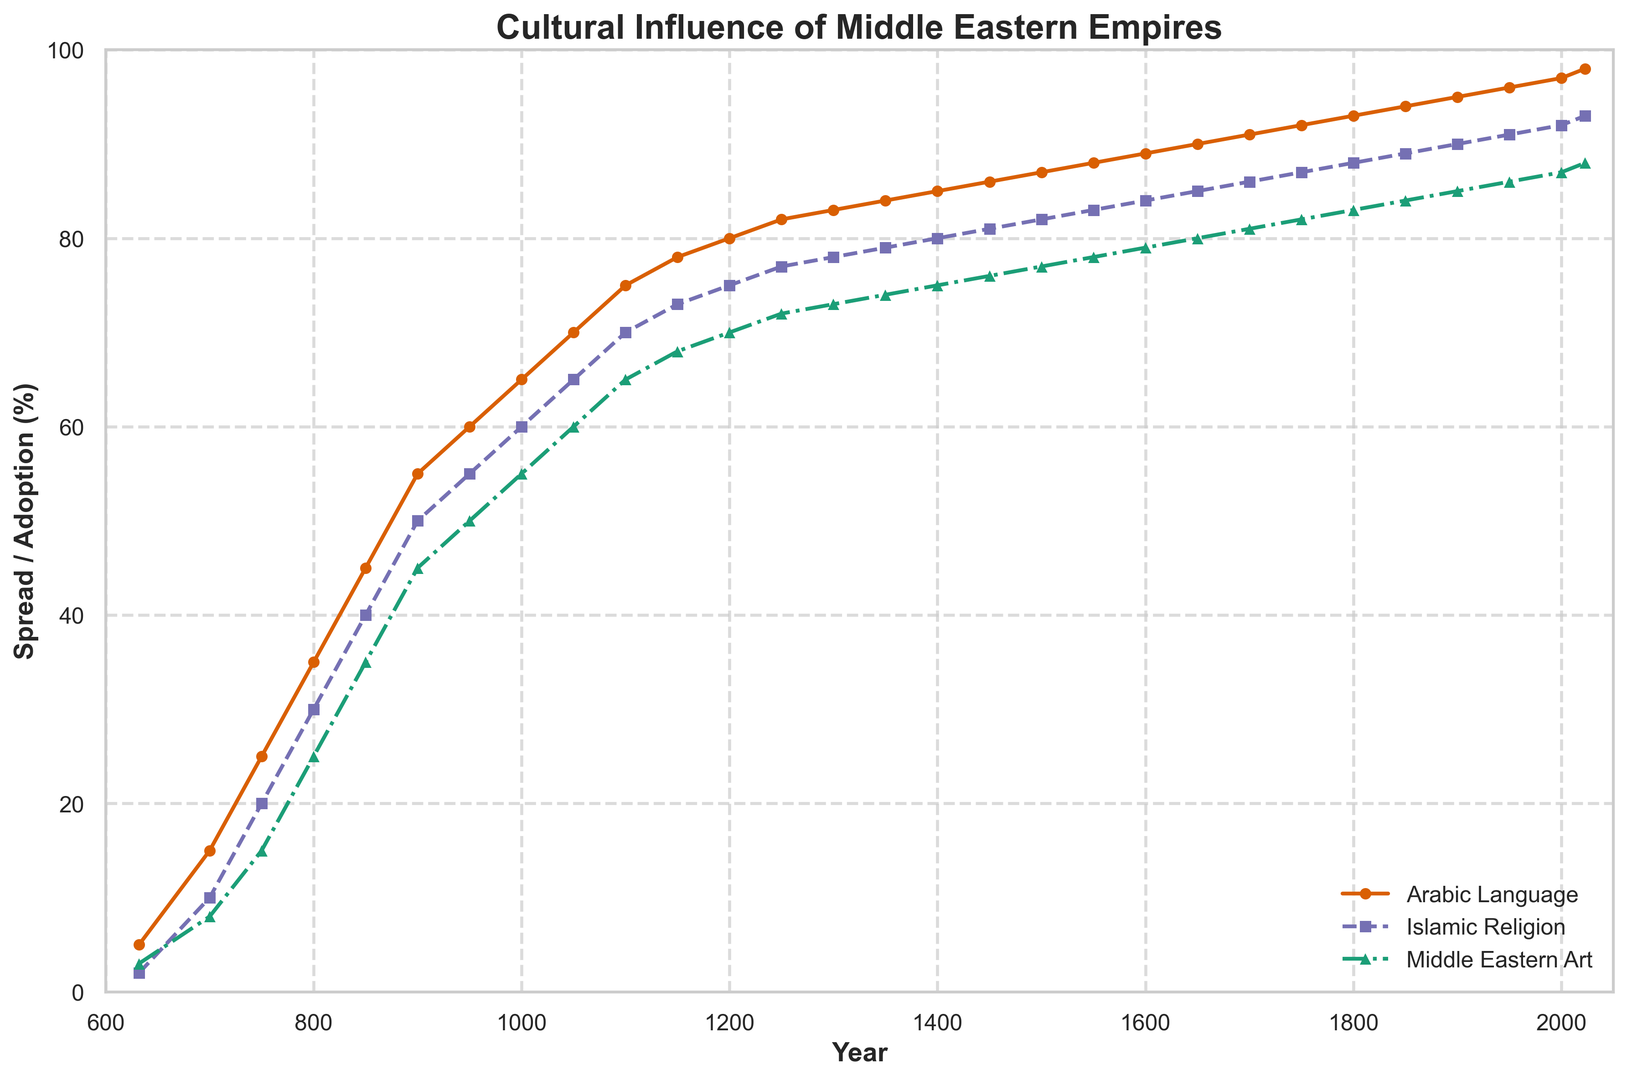What year did the Arabic Language Spread (%), Islamic Religion Spread (%), and Middle Eastern Art Style Adoption (%) first reach 50%? To find this, look at where each line first intersects the 50% mark on the y-axis. The Arabic Language reaches 50% around 900; Islamic Religion reaches it around 950; Middle Eastern Art Style reaches it around 1000.
Answer: Arabic Language: 900, Islamic Religion: 950, Middle Eastern Art Style: 1000 In which year did the spread of Islamic Religion most closely match the adoption of Middle Eastern Art Style? This requires comparing the two lines throughout the plot to find the year where their values are closest. By examining the lines, around the year 900, both spreads are around 50%.
Answer: 900 By how much did the spread of the Arabic Language (%) increase between 700 and 1300? Determine the spread of the Arabic Language in 700 and 1300, then calculate the difference: 83% - 15% = 68%.
Answer: 68% How does the spread of Islamic Religion (%) compare to the adoption of Middle Eastern Art Styles (%) in 1200? Look at the y-axis value for both lines in 1200. The spread of Islamic Religion is 75%, and the adoption of Middle Eastern Art Styles is 70%.
Answer: Islamic Religion: 75%, Middle Eastern Art Style: 70% Between the years 632 and 2023, which cultural influence increased the most? Calculate the increase for each cultural influence by subtracting the initial value from the final value: Arabic Language: 98% - 5% = 93%, Islamic Religion: 93% - 2% = 91%, Middle Eastern Art Style: 88% - 3% = 85%. The Arabic Language spread increased the most.
Answer: Arabic Language In the year 1500, which cultural influence was most prevalent? Check the y-axis values for the year 1500 for all three cultural influences. Arabic Language is at 87%, Islamic Religion is at 82%, and Middle Eastern Art Style is at 77%.
Answer: Arabic Language What is the rate of increase per century for Middle Eastern Art Style Adoption (%) from 1000 to 1100? Calculate the change in percentage over the period, then divide by the number of centuries: (65% - 55%) = 10% over 100 years, so the rate is 10%/century.
Answer: 10%/century How do the adoption trends of Middle Eastern Art Styles and the spread of the Arabic Language compare over time? Visually compare the trends of the two lines. Both lines steadily rise, but Arabic Language spread consistently outpaces Middle Eastern Art Style adoption throughout the entire period.
Answer: Arabic Language exceeds Art Style Which time period saw the fastest increase in the spread of the Islamic Religion (%)? Look for the steepest slope in the Islamic Religion line, which occurs between 700 and 800, where it increases from 10% to 30%.
Answer: 700-800 What is the difference in the spread of the Arabic Language (%) between 1300 and 1450? Determine the percentage spread for these years and subtract: 86% - 83% = 3%.
Answer: 3% 